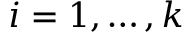<formula> <loc_0><loc_0><loc_500><loc_500>i = 1 , \dots , k</formula> 